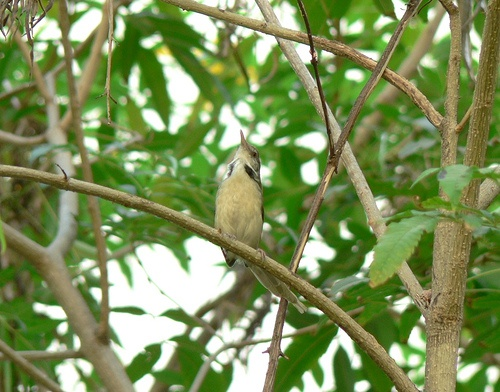Describe the objects in this image and their specific colors. I can see a bird in gray, tan, darkgreen, and olive tones in this image. 